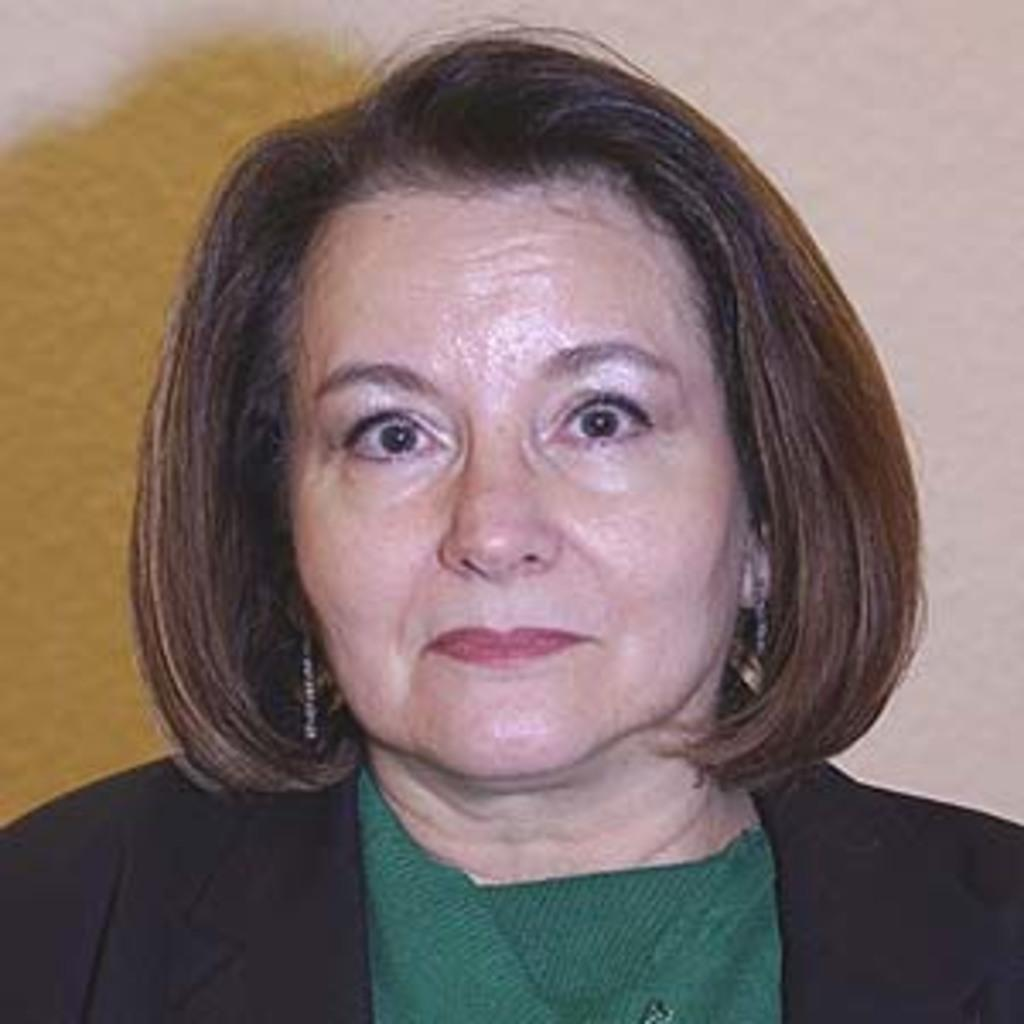Who is present in the image? There is a woman in the image. What can be seen in the background of the image? There is a wall in the background of the image. What type of glue is the woman using to stick tomatoes on the wall in the image? There is no glue or tomatoes present in the image; it only features a woman and a wall in the background. 